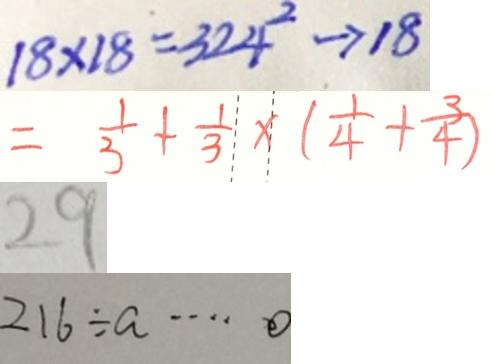<formula> <loc_0><loc_0><loc_500><loc_500>1 8 \times 1 8 = 3 2 4 ^ { 2 } \rightarrow 1 8 
 = \frac { 1 } { 3 } + \frac { 1 } { 3 } \times ( \frac { 1 } { 4 } + \frac { 3 } { 4 } ) 
 2 9 
 2 1 6 \div a \cdots 0</formula> 